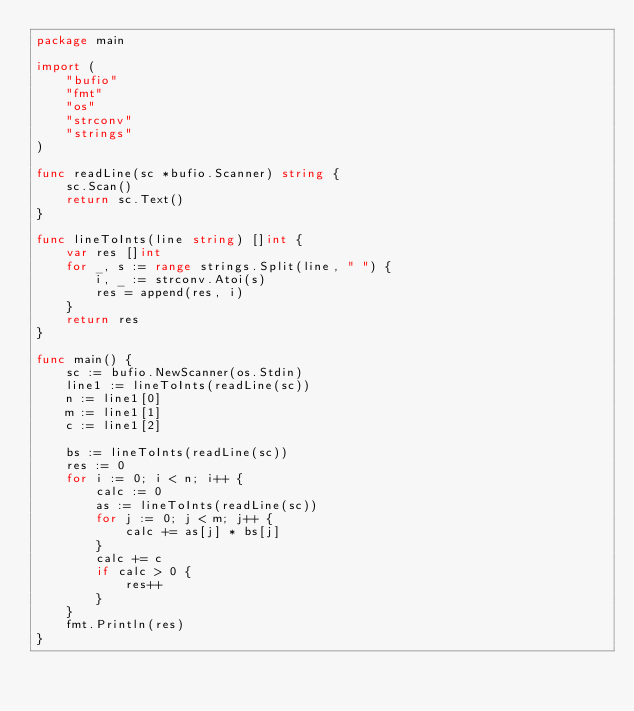Convert code to text. <code><loc_0><loc_0><loc_500><loc_500><_Go_>package main

import (
	"bufio"
	"fmt"
	"os"
	"strconv"
	"strings"
)

func readLine(sc *bufio.Scanner) string {
	sc.Scan()
	return sc.Text()
}

func lineToInts(line string) []int {
	var res []int
	for _, s := range strings.Split(line, " ") {
		i, _ := strconv.Atoi(s)
		res = append(res, i)
	}
	return res
}

func main() {
	sc := bufio.NewScanner(os.Stdin)
	line1 := lineToInts(readLine(sc))
	n := line1[0]
	m := line1[1]
	c := line1[2]

	bs := lineToInts(readLine(sc))
	res := 0
	for i := 0; i < n; i++ {
		calc := 0
		as := lineToInts(readLine(sc))
		for j := 0; j < m; j++ {
			calc += as[j] * bs[j]
		}
		calc += c
		if calc > 0 {
			res++
		}
	}
	fmt.Println(res)
}
</code> 